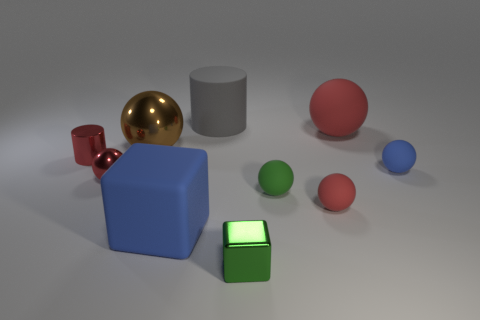What number of big red matte blocks are there?
Offer a very short reply. 0. There is a tiny red ball left of the cylinder that is behind the big sphere that is to the right of the big blue block; what is its material?
Offer a terse response. Metal. Is there a small sphere made of the same material as the tiny red cylinder?
Your answer should be very brief. Yes. Is the material of the red cylinder the same as the blue ball?
Provide a succinct answer. No. How many spheres are either tiny green objects or big gray things?
Your answer should be very brief. 1. The block that is made of the same material as the tiny blue sphere is what color?
Your answer should be compact. Blue. Are there fewer big brown matte spheres than tiny red metallic spheres?
Your answer should be compact. Yes. There is a blue matte object that is in front of the small blue rubber sphere; does it have the same shape as the tiny shiny thing to the right of the gray rubber thing?
Your answer should be very brief. Yes. How many things are tiny things or large green rubber spheres?
Give a very brief answer. 6. There is a metallic block that is the same size as the red shiny ball; what is its color?
Offer a very short reply. Green. 